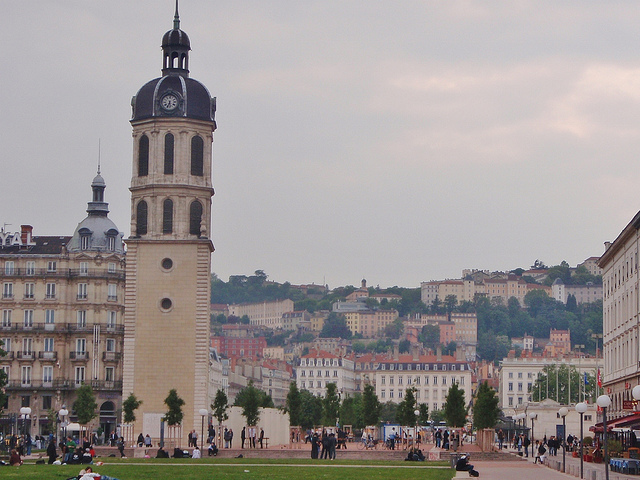<image>What is the towers name? I don't know the name of the tower. It could be 'big ben', 'taj', 'long tower', 'clock tower', 'big tower', 'cable tower', 'eiffel', or 'bob'. What is the towers name? I am not sure about the tower's name. It can be seen as 'big ben', 'taj', 'long tower', 'clock tower', 'big tower', 'cable tower', 'eiffel', or 'bob'. 